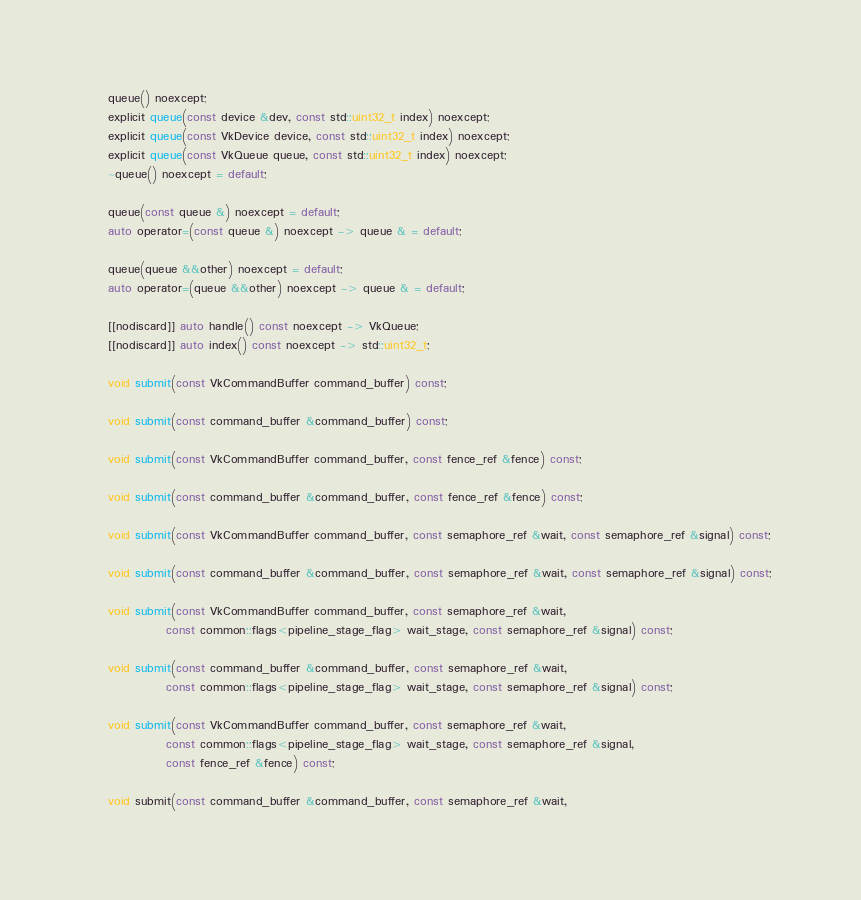Convert code to text. <code><loc_0><loc_0><loc_500><loc_500><_C_>    queue() noexcept;
    explicit queue(const device &dev, const std::uint32_t index) noexcept;
    explicit queue(const VkDevice device, const std::uint32_t index) noexcept;
    explicit queue(const VkQueue queue, const std::uint32_t index) noexcept;
    ~queue() noexcept = default;

    queue(const queue &) noexcept = default;
    auto operator=(const queue &) noexcept -> queue & = default;

    queue(queue &&other) noexcept = default;
    auto operator=(queue &&other) noexcept -> queue & = default;

    [[nodiscard]] auto handle() const noexcept -> VkQueue;
    [[nodiscard]] auto index() const noexcept -> std::uint32_t;

    void submit(const VkCommandBuffer command_buffer) const;

    void submit(const command_buffer &command_buffer) const;

    void submit(const VkCommandBuffer command_buffer, const fence_ref &fence) const;

    void submit(const command_buffer &command_buffer, const fence_ref &fence) const;

    void submit(const VkCommandBuffer command_buffer, const semaphore_ref &wait, const semaphore_ref &signal) const;

    void submit(const command_buffer &command_buffer, const semaphore_ref &wait, const semaphore_ref &signal) const;

    void submit(const VkCommandBuffer command_buffer, const semaphore_ref &wait,
                const common::flags<pipeline_stage_flag> wait_stage, const semaphore_ref &signal) const;

    void submit(const command_buffer &command_buffer, const semaphore_ref &wait,
                const common::flags<pipeline_stage_flag> wait_stage, const semaphore_ref &signal) const;

    void submit(const VkCommandBuffer command_buffer, const semaphore_ref &wait,
                const common::flags<pipeline_stage_flag> wait_stage, const semaphore_ref &signal,
                const fence_ref &fence) const;

    void submit(const command_buffer &command_buffer, const semaphore_ref &wait,</code> 